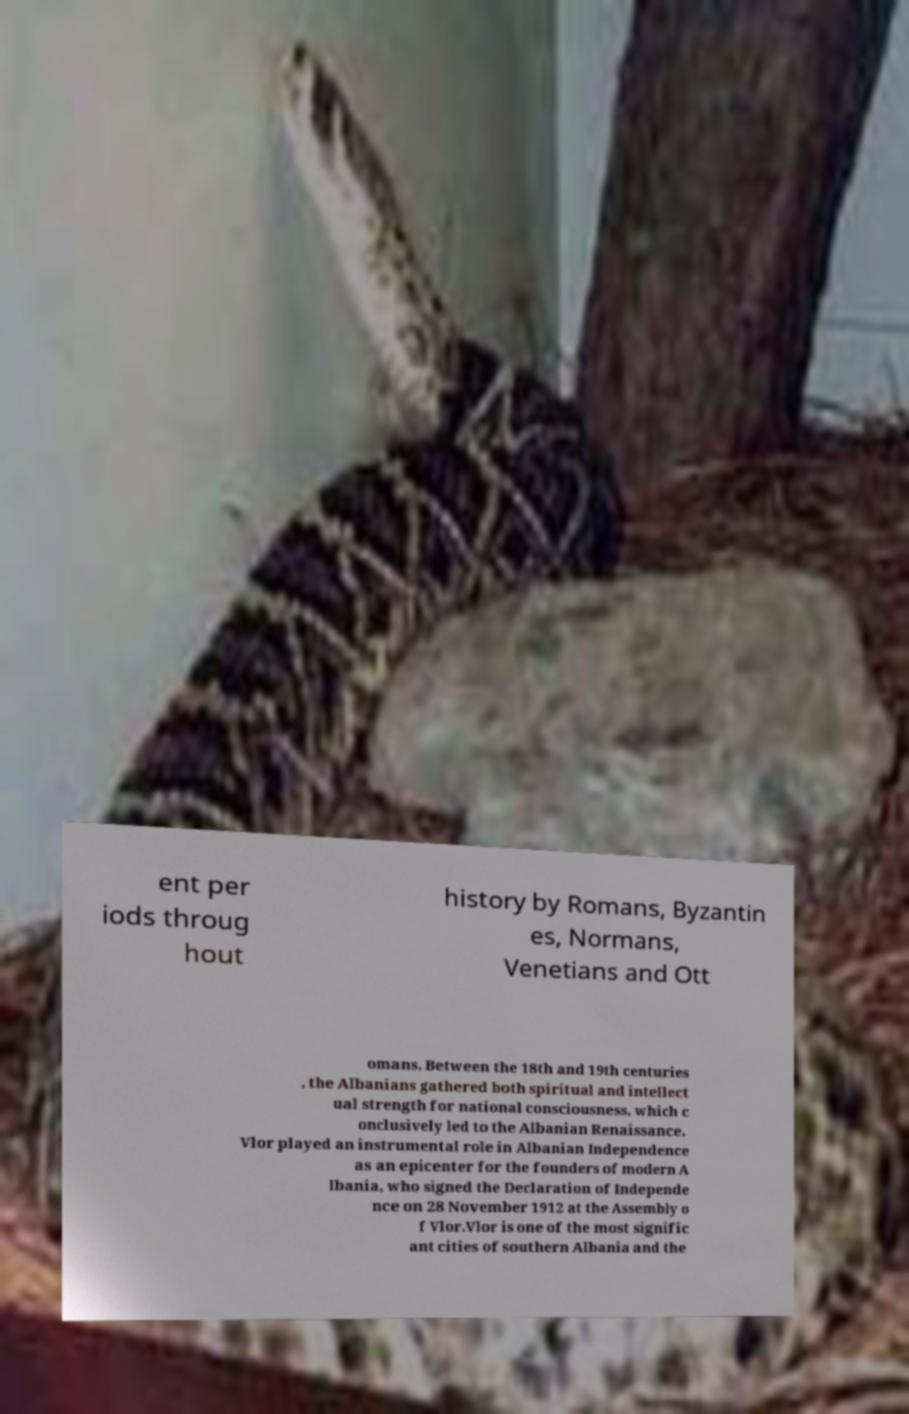Can you read and provide the text displayed in the image?This photo seems to have some interesting text. Can you extract and type it out for me? ent per iods throug hout history by Romans, Byzantin es, Normans, Venetians and Ott omans. Between the 18th and 19th centuries , the Albanians gathered both spiritual and intellect ual strength for national consciousness, which c onclusively led to the Albanian Renaissance. Vlor played an instrumental role in Albanian Independence as an epicenter for the founders of modern A lbania, who signed the Declaration of Independe nce on 28 November 1912 at the Assembly o f Vlor.Vlor is one of the most signific ant cities of southern Albania and the 